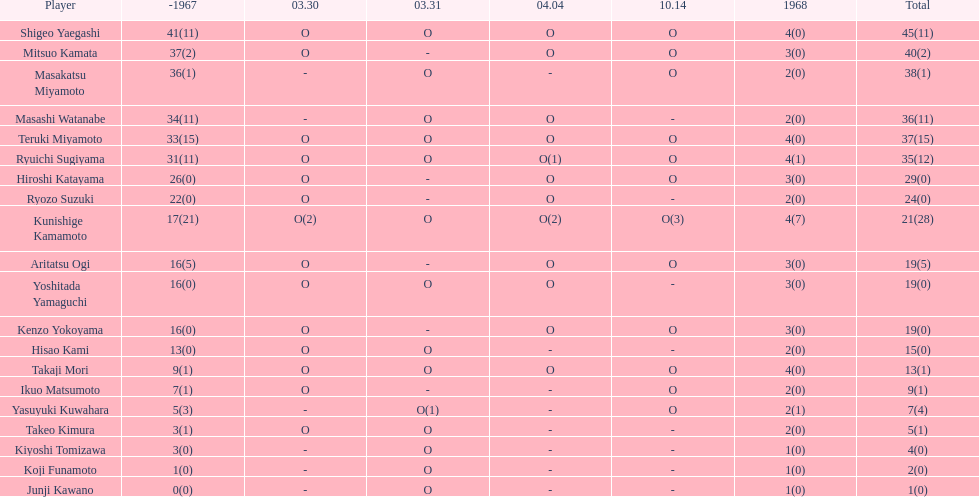Did mitsuo kamata have more than 40 total points? No. 